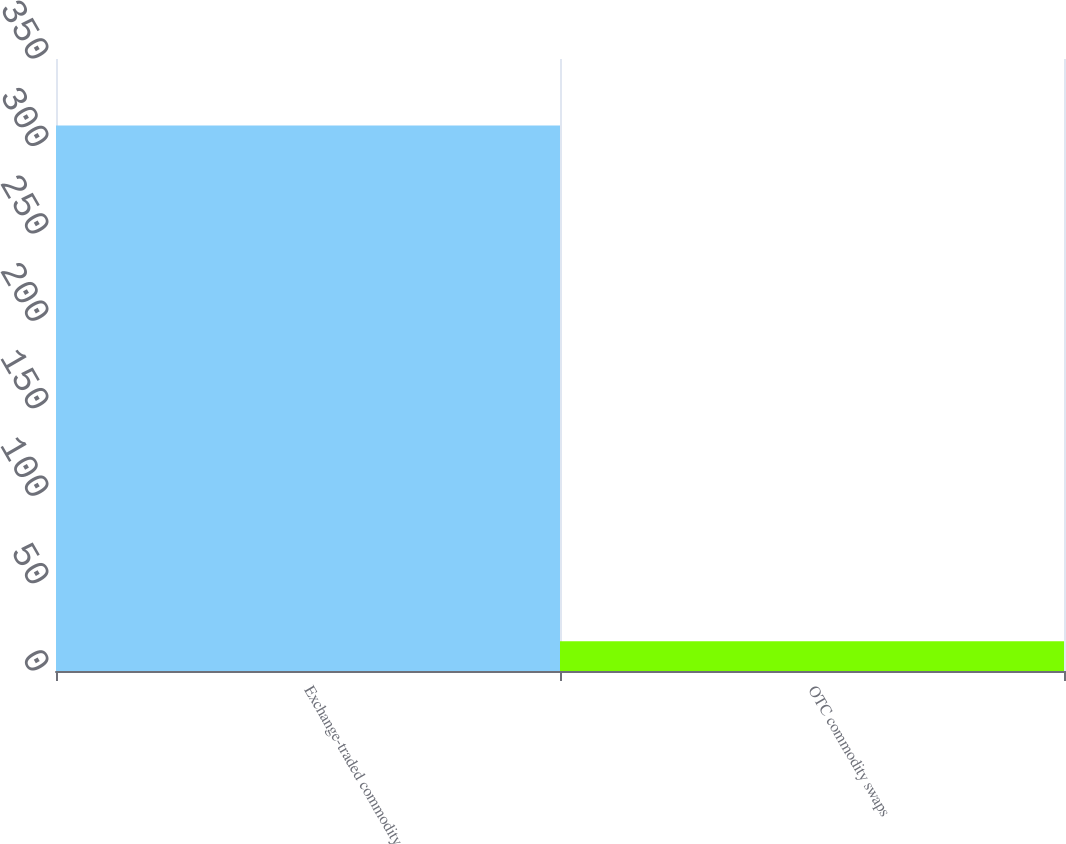<chart> <loc_0><loc_0><loc_500><loc_500><bar_chart><fcel>Exchange-traded commodity<fcel>OTC commodity swaps<nl><fcel>312<fcel>17<nl></chart> 